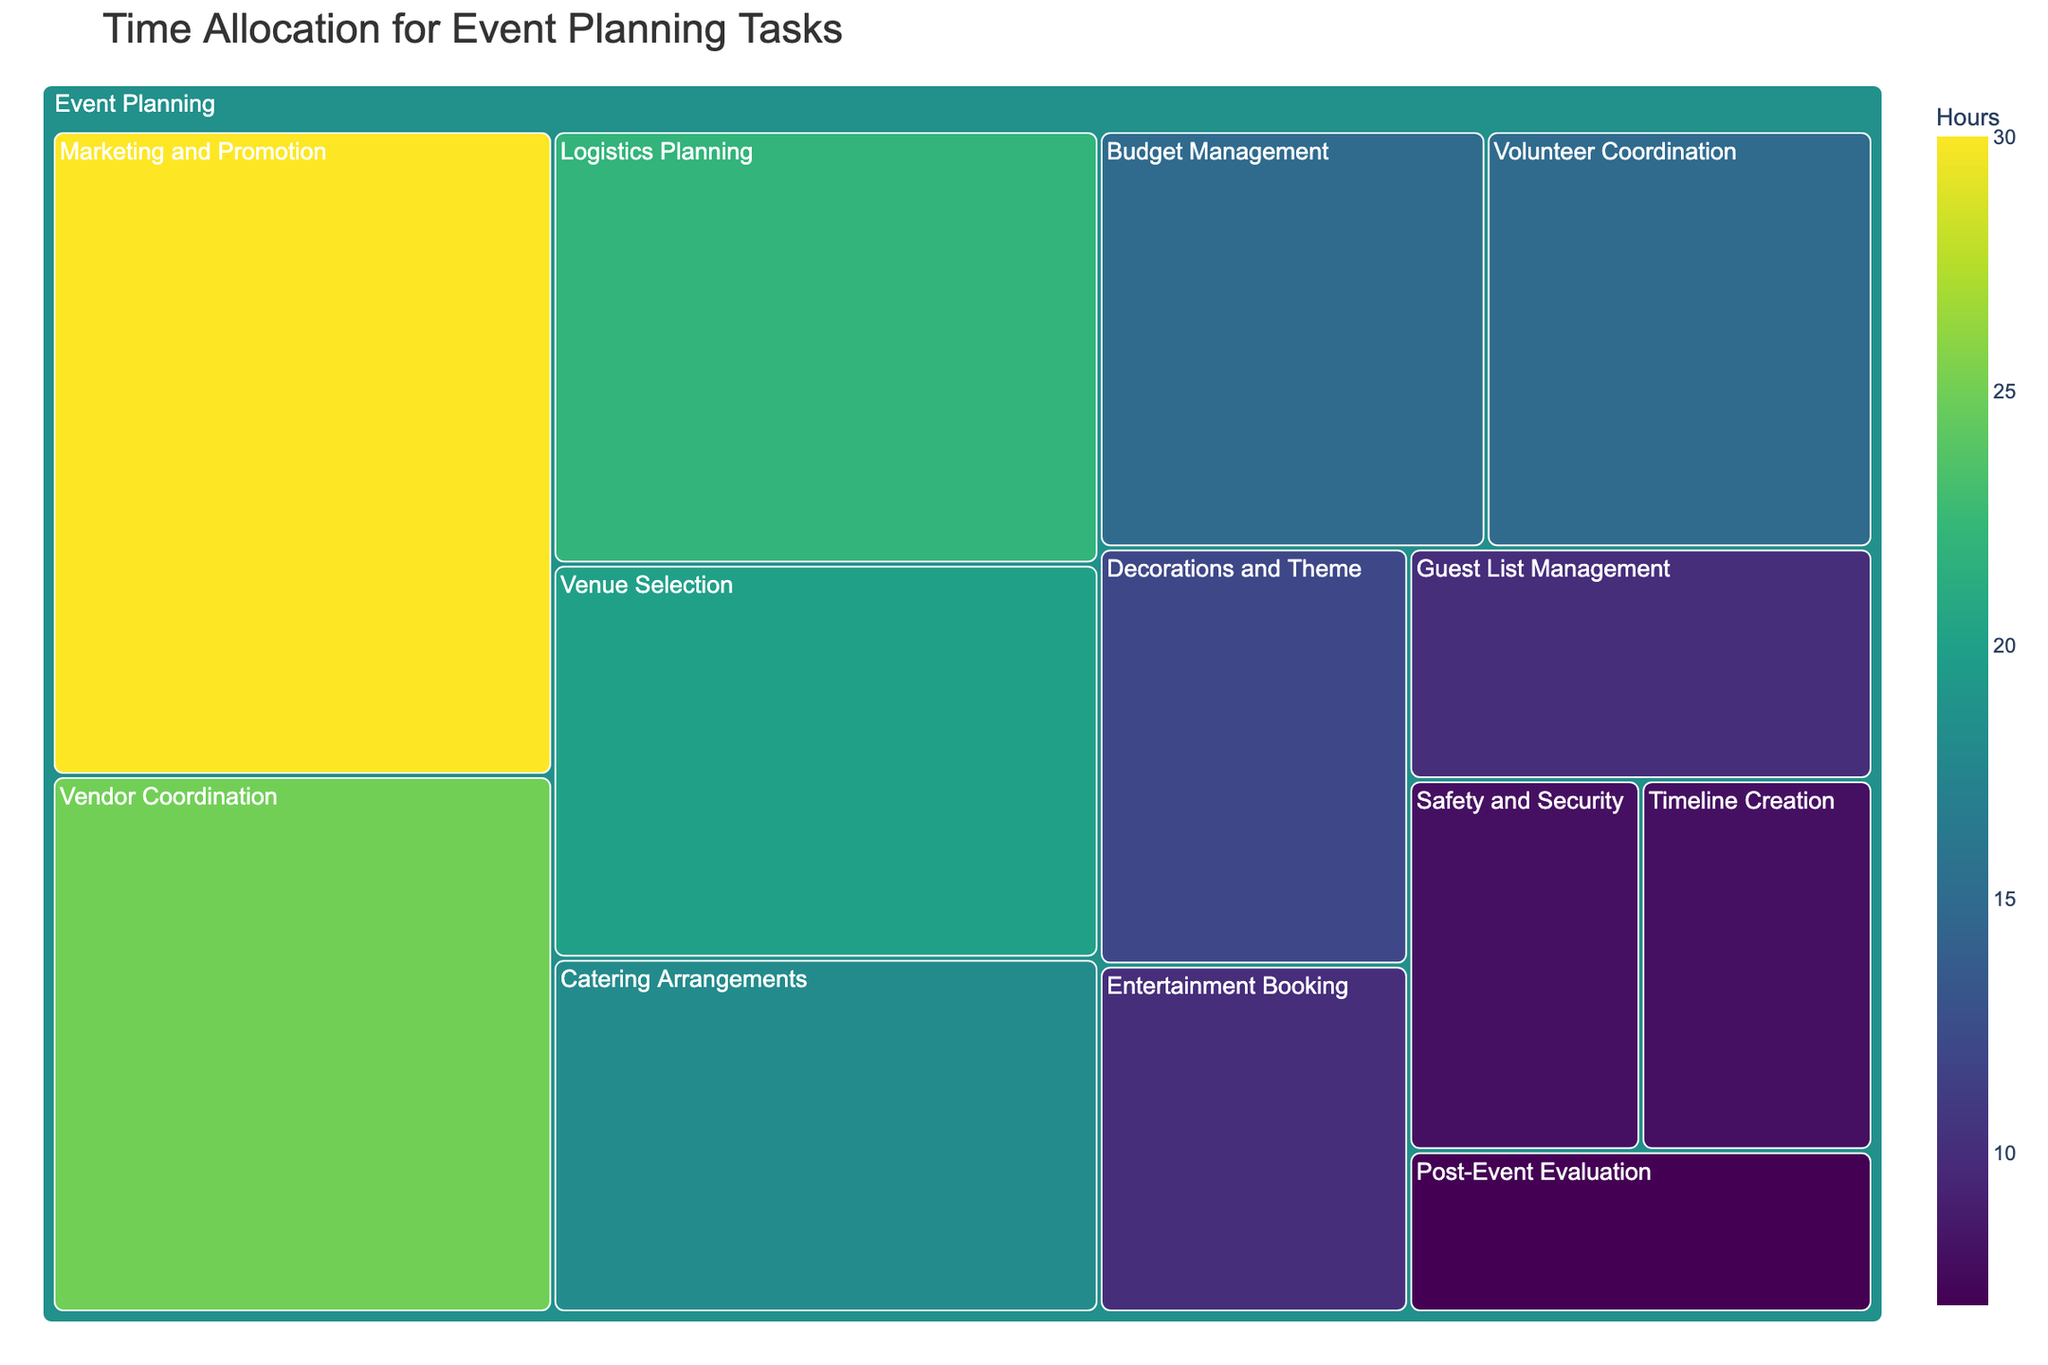What's the title of the treemap? The title is usually shown at the top of the figure, summarizing the content and purpose of the treemap. From the data provided, the title is "Time Allocation for Event Planning Tasks."
Answer: Time Allocation for Event Planning Tasks Which task has the highest allocation of time? The largest area in the treemap will represent the task with the highest allocation of time. Here, it's "Marketing and Promotion" with 30 hours.
Answer: Marketing and Promotion How many hours are allocated to "Venue Selection"? By locating the "Venue Selection" block in the treemap, you can see it is allocated 20 hours.
Answer: 20 hours What is the difference in hours between "Vendor Coordination" and "Guest List Management"? Subtract the hours of "Guest List Management" (10) from "Vendor Coordination" (25) to find the difference. 25 - 10 = 15 hours.
Answer: 15 hours What is the total amount of time spent on "Safety and Security" and "Timeline Creation"? Add the hours of "Safety and Security" (8) and "Timeline Creation" (8) together. 8 + 8 = 16 hours.
Answer: 16 hours Which task has fewer hours allocated to it: "Logistics Planning" or "Catering Arrangements"? From the treemap, "Logistics Planning" is 22 hours and "Catering Arrangements" is 18 hours. Comparing these, "Catering Arrangements" has fewer hours.
Answer: Catering Arrangements How does the time allocated to "Decorations and Theme" compare to "Post-Event Evaluation"? "Decorations and Theme" is 12 hours, and "Post-Event Evaluation" is 7 hours. Comparing these, "Decorations and Theme" has more hours allocated.
Answer: Decorations and Theme What is the average number of hours spent on "Volunteer Coordination," "Budget Management," and "Entertainment Booking"? First, find the sum of hours for these tasks: 15 (Volunteer Coordination) + 15 (Budget Management) + 10 (Entertainment Booking) = 40 hours. Then divide by the number of tasks: 40 / 3 ≈ 13.33 hours.
Answer: 13.33 hours Which task has the smallest allocation of time and how many hours is it? Identify the smallest block in the treemap, which represents the smallest allocation. It is "Post-Event Evaluation" with 7 hours.
Answer: Post-Event Evaluation, 7 hours What is the combined time allocation for tasks related to "Volunteer Coordination" and "Logistics Planning"? Add the hours of "Volunteer Coordination" (15) and "Logistics Planning" (22): 15 + 22 = 37 hours.
Answer: 37 hours 